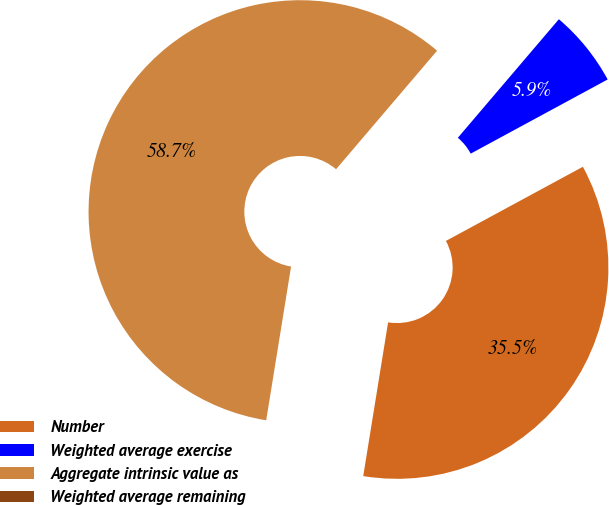<chart> <loc_0><loc_0><loc_500><loc_500><pie_chart><fcel>Number<fcel>Weighted average exercise<fcel>Aggregate intrinsic value as<fcel>Weighted average remaining<nl><fcel>35.45%<fcel>5.87%<fcel>58.68%<fcel>0.0%<nl></chart> 